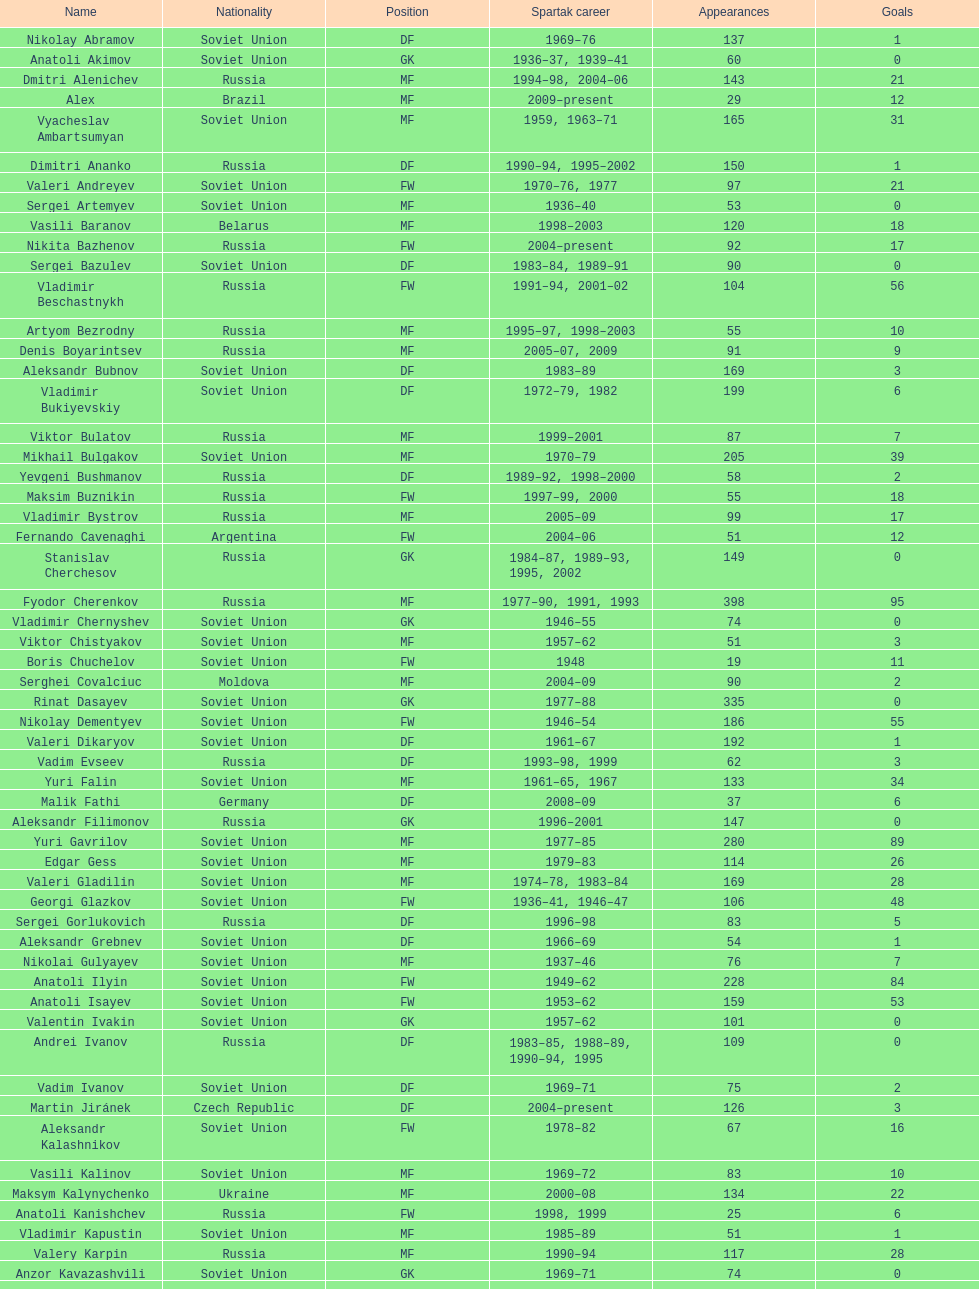Vladimir bukiyevskiy had how many appearances? 199. 